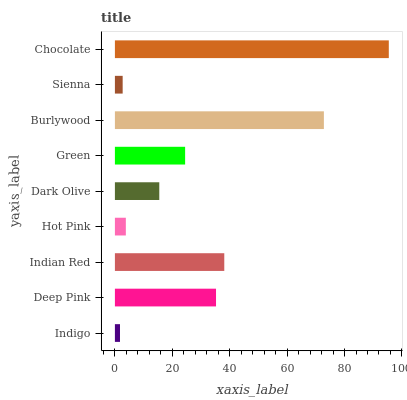Is Indigo the minimum?
Answer yes or no. Yes. Is Chocolate the maximum?
Answer yes or no. Yes. Is Deep Pink the minimum?
Answer yes or no. No. Is Deep Pink the maximum?
Answer yes or no. No. Is Deep Pink greater than Indigo?
Answer yes or no. Yes. Is Indigo less than Deep Pink?
Answer yes or no. Yes. Is Indigo greater than Deep Pink?
Answer yes or no. No. Is Deep Pink less than Indigo?
Answer yes or no. No. Is Green the high median?
Answer yes or no. Yes. Is Green the low median?
Answer yes or no. Yes. Is Hot Pink the high median?
Answer yes or no. No. Is Chocolate the low median?
Answer yes or no. No. 